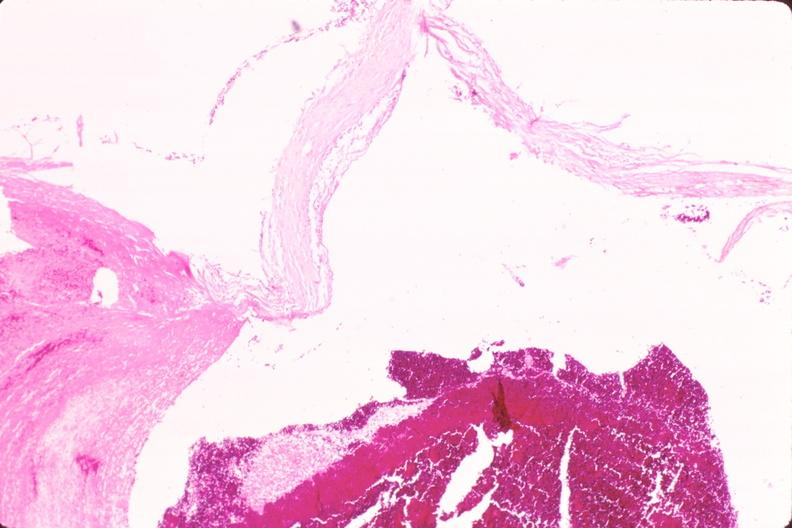what is present?
Answer the question using a single word or phrase. Vasculature 